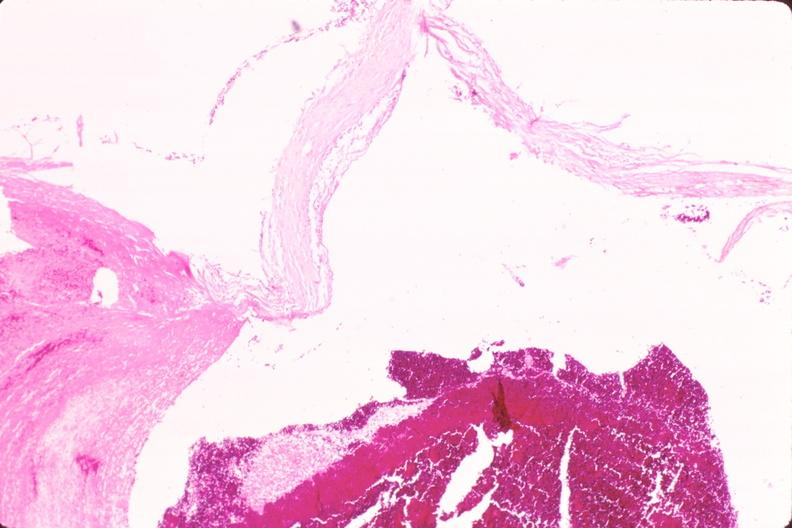what is present?
Answer the question using a single word or phrase. Vasculature 